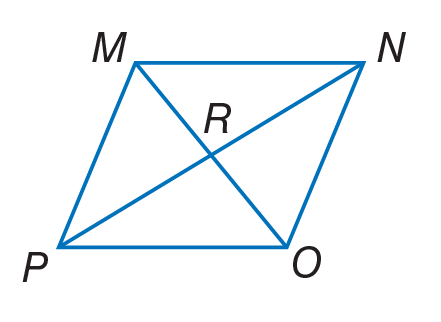Answer the mathemtical geometry problem and directly provide the correct option letter.
Question: Quadrilateral M N O P is a rhombus. If m \angle P O N = 124, find m \angle P O M.
Choices: A: 12 B: 56 C: 62 D: 124 C 